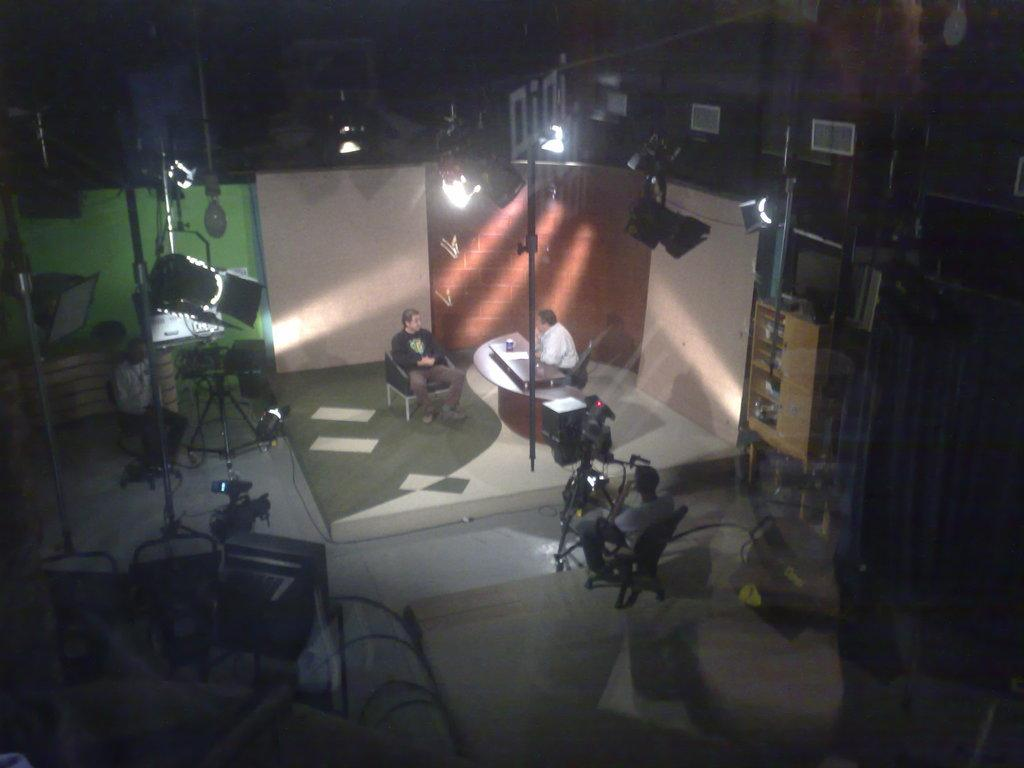What type of structure can be seen in the image? There is a wall in the image. What can be seen illuminating the area in the image? There are lights in the image. What are the people in the image doing? There are people sitting on chairs in the image. What device is used to capture images in the image? A camera is visible in the image. What piece of furniture is present in the image? There is a table in the image. Can you tell me how many ducks are sitting on the chairs in the image? There are no ducks present in the image; it features people sitting on chairs. What type of yoke is used to control the camera in the image? There is no yoke present in the image, as cameras do not require yokes for control. 